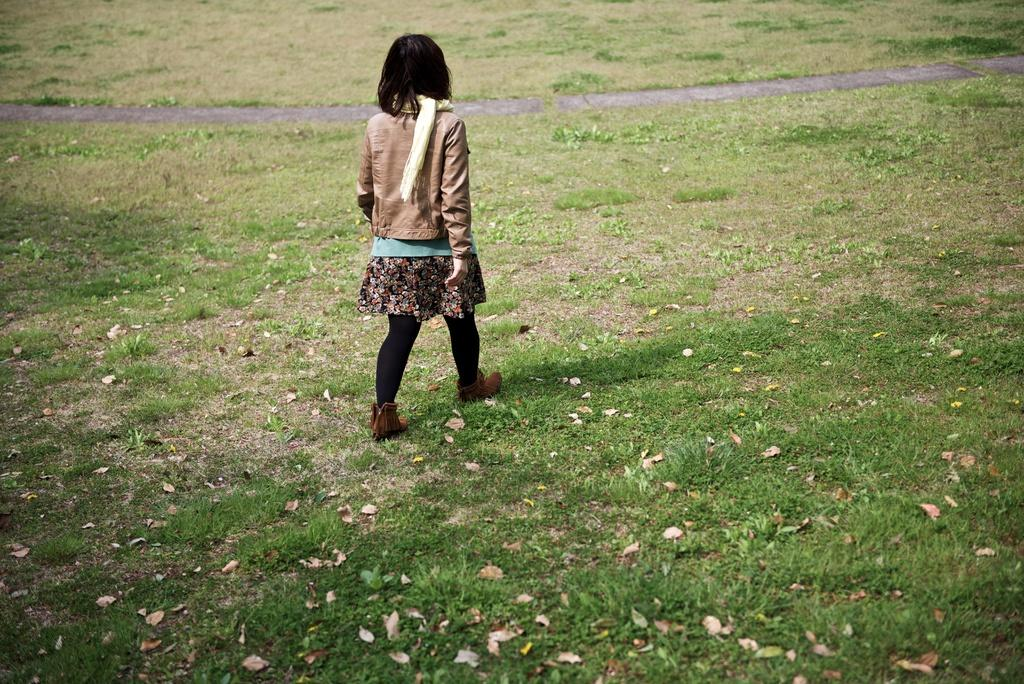What colors are present in the dress that the person is wearing in the image? The dress has brown, green, and black colors. What is the person's position in the image? The person is on the ground. What type of surface can be seen in the image? There is a road visible in the image. What type of popcorn is being served during the news broadcast in the image? There is no popcorn or news broadcast present in the image. What holiday is being celebrated in the image? There is no indication of a holiday being celebrated in the image. 